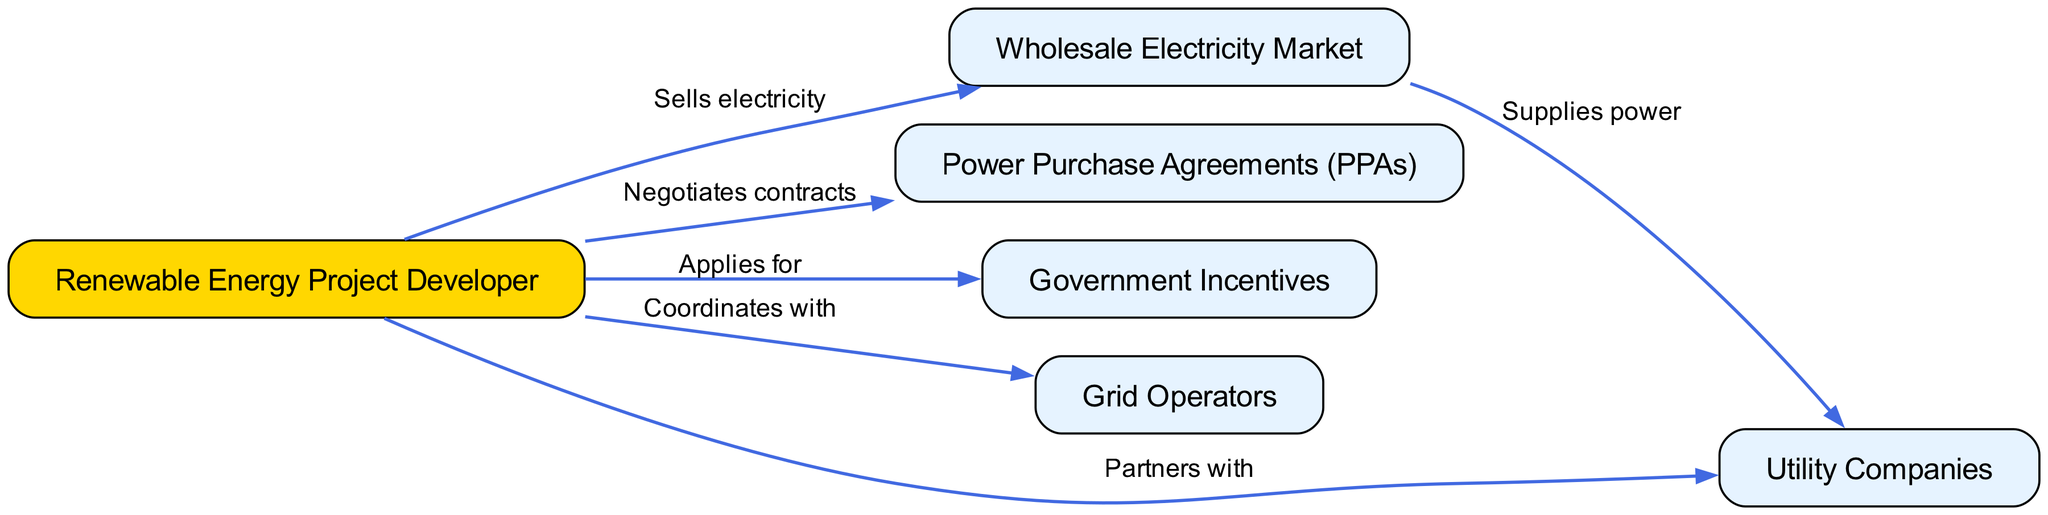What is the main actor in the diagram? The main actor is represented by the first node, labeled "Renewable Energy Project Developer." This node appears prominently and is the origin point for the connections in the diagram.
Answer: Renewable Energy Project Developer How many nodes are there in total? By counting the nodes listed in the diagram data, we can see there are six distinct nodes: one for the developer, one for the wholesale market, one for PPAs, one for government incentives, one for grid operators, and one for utility companies.
Answer: 6 What does the Renewable Energy Project Developer do with the Wholesale Electricity Market? The connection between these two nodes is labeled "Sells electricity," indicating that the developer engages in a selling relationship with the wholesale market. This relationship is fundamental for the developer's operations.
Answer: Sells electricity Which entities does the Renewable Energy Project Developer partner with? The diagram shows a direct connection from the developer to the Utility Companies, which is labeled "Partners with." This indicates a collaborative relationship essential for implementing renewable energy projects at a local level.
Answer: Utility Companies What kind of agreements does the Renewable Energy Project Developer negotiate? The edge between the developer and the Power Purchase Agreements (PPAs) is labeled "Negotiates contracts." This indicates that part of the developer's role involves securing long-term contracts to sell electricity generated from their projects.
Answer: Contracts What is the relationship between the Wholesale Electricity Market and Utility Companies? The relationship is indicated by the edge labeled "Supplies power," demonstrating that the wholesale market supplies electricity to utility companies, which then distribute it to consumers.
Answer: Supplies power What action does the Renewable Energy Project Developer take regarding Government Incentives? The labeled connection from the developer to Government Incentives states "Applies for," indicating that the developer actively seeks governmental support or benefits that can aid their renewable energy projects financially or otherwise.
Answer: Applies for How does the Renewable Energy Project Developer interact with Grid Operators? The connection labeled "Coordinates with" shows that the developer collaborates with grid operators, which is crucial for ensuring the integration of their renewable energy sources into the existing energy grid system.
Answer: Coordinates with How many edges are directed from the Renewable Energy Project Developer? By examining the edges, we can see that there are five outgoing edges originating from the developer, connecting to the wholesale market, power purchase agreements, government incentives, grid operators, and utility companies.
Answer: 5 